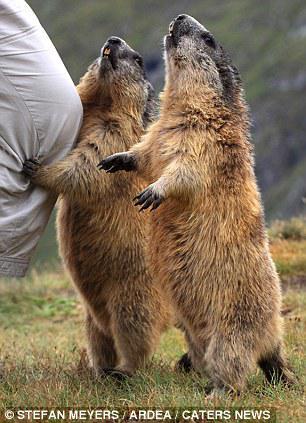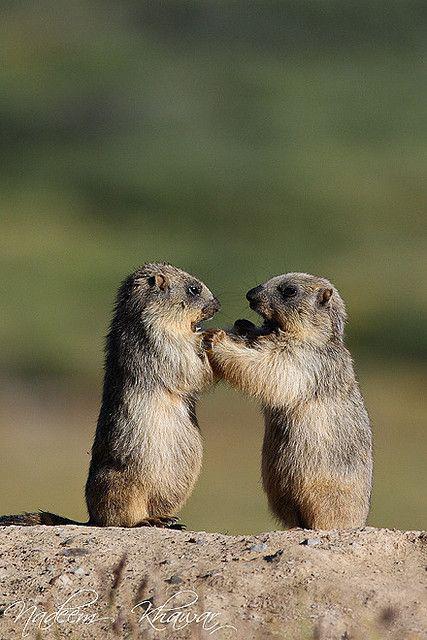The first image is the image on the left, the second image is the image on the right. Assess this claim about the two images: "there are no less then 3 animals in the right pic". Correct or not? Answer yes or no. No. 